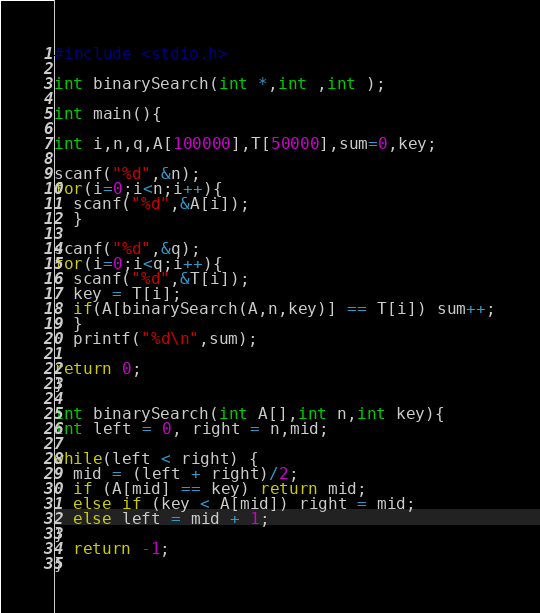<code> <loc_0><loc_0><loc_500><loc_500><_C_>#include <stdio.h>

int binarySearch(int *,int ,int );

int main(){

int i,n,q,A[100000],T[50000],sum=0,key;

scanf("%d",&n);
for(i=0;i<n;i++){
  scanf("%d",&A[i]);
  }

scanf("%d",&q);
for(i=0;i<q;i++){
  scanf("%d",&T[i]);
  key = T[i];
  if(A[binarySearch(A,n,key)] == T[i]) sum++;
  }
  printf("%d\n",sum);

return 0;
}

int binarySearch(int A[],int n,int key){
int left = 0, right = n,mid;

while(left < right) {
  mid = (left + right)/2;
  if (A[mid] == key) return mid;
  else if (key < A[mid]) right = mid;
  else left = mid + 1;
}
  return -1;
}</code> 